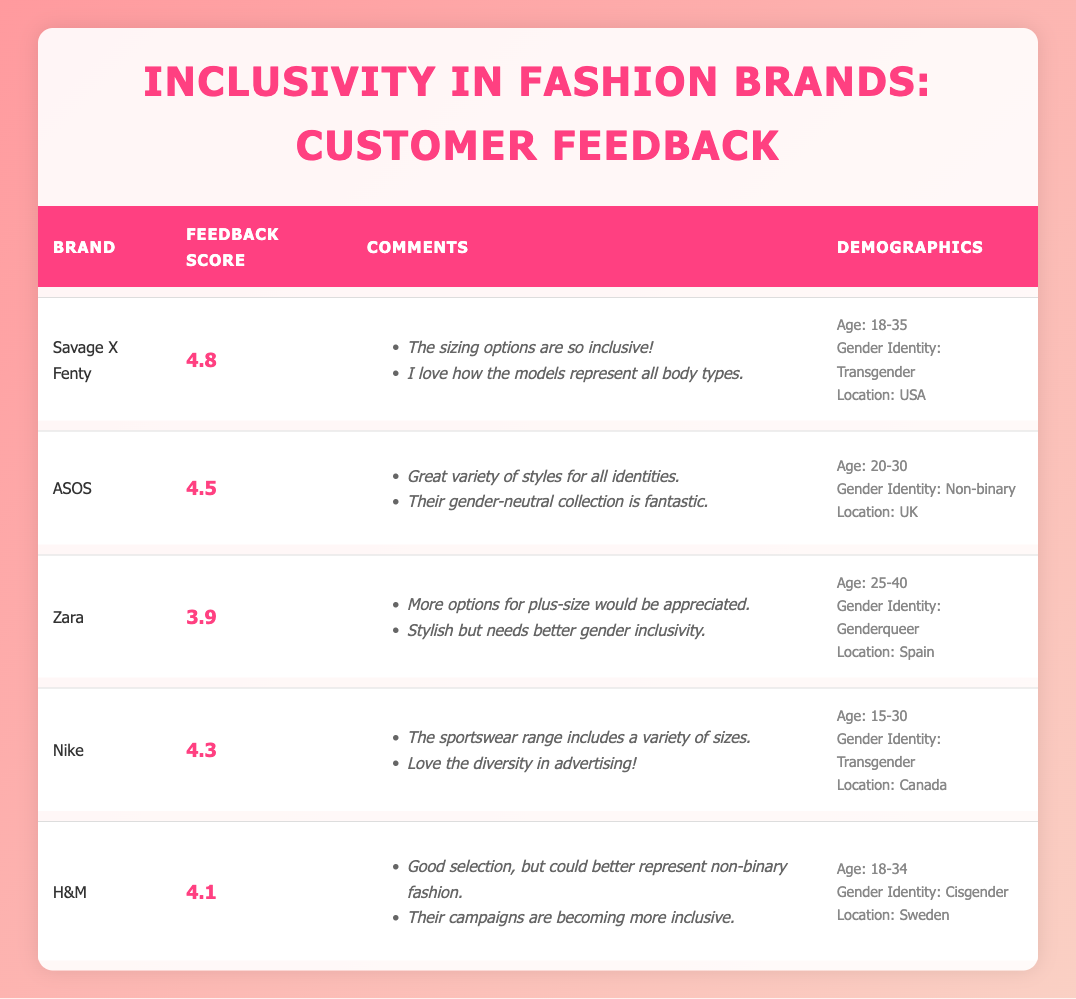What brand received the highest feedback score? By examining the feedback scores in the table, we can see that Savage X Fenty has the highest score of 4.8.
Answer: Savage X Fenty Which brand's feedback comments mention "gender-neutral collection"? Looking through the comments, ASOS is the brand that specifically mentions "Their gender-neutral collection is fantastic."
Answer: ASOS What is the average feedback score of the brands listed? To find the average, we first sum the feedback scores: 4.8 + 4.5 + 3.9 + 4.3 + 4.1 = 21.6. Then, we divide the total by the number of brands (5) to get the average: 21.6/5 = 4.32.
Answer: 4.32 Is Zara's feedback score higher than Nike's? Comparing the feedback scores, Zara has a score of 3.9 while Nike has a score of 4.3. Since 3.9 is less than 4.3, the answer is no.
Answer: No Which demographic category has the highest representation among the feedback comments? We look at the demographic categories across all entries and find three mentions of "Transgender" (from Savage X Fenty and Nike) and two mentions of "Non-binary" (from ASOS) and "Genderqueer" (from Zara) plus one for "Cisgender" (from H&M). Therefore, "Transgender" has the highest representation with two entries.
Answer: Transgender What specific feedback did customers provide for H&M? Checking the comments for H&M, the customers noted: "Good selection, but could better represent non-binary fashion" and "Their campaigns are becoming more inclusive."
Answer: Good selection, but could better represent non-binary fashion; Their campaigns are becoming more inclusive What percentage of the feedback entries are from individuals identifying as Transgender? There are two entries that identify as Transgender out of five total entries. To find the percentage, we do (2/5) * 100 = 40%.
Answer: 40% Is the location with the most entries in the USA? The locations of the feedback entries are: USA, UK, Spain, Canada, and Sweden. Since there is only one entry from the USA, it does not have the highest representation compared to the others, which have one entry each.
Answer: No 